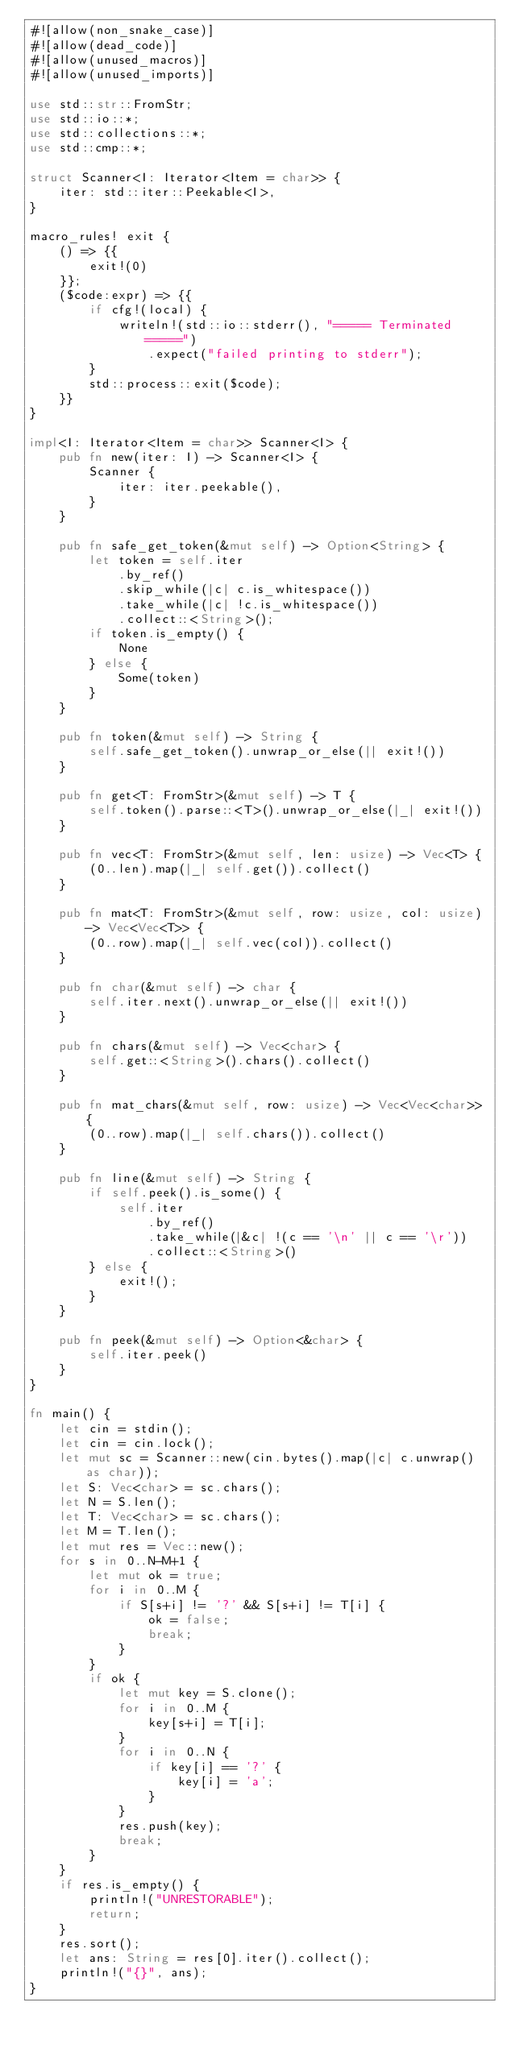<code> <loc_0><loc_0><loc_500><loc_500><_Rust_>#![allow(non_snake_case)]
#![allow(dead_code)]
#![allow(unused_macros)]
#![allow(unused_imports)]

use std::str::FromStr;
use std::io::*;
use std::collections::*;
use std::cmp::*;

struct Scanner<I: Iterator<Item = char>> {
    iter: std::iter::Peekable<I>,
}

macro_rules! exit {
    () => {{
        exit!(0)
    }};
    ($code:expr) => {{
        if cfg!(local) {
            writeln!(std::io::stderr(), "===== Terminated =====")
                .expect("failed printing to stderr");
        }
        std::process::exit($code);
    }}
}

impl<I: Iterator<Item = char>> Scanner<I> {
    pub fn new(iter: I) -> Scanner<I> {
        Scanner {
            iter: iter.peekable(),
        }
    }

    pub fn safe_get_token(&mut self) -> Option<String> {
        let token = self.iter
            .by_ref()
            .skip_while(|c| c.is_whitespace())
            .take_while(|c| !c.is_whitespace())
            .collect::<String>();
        if token.is_empty() {
            None
        } else {
            Some(token)
        }
    }

    pub fn token(&mut self) -> String {
        self.safe_get_token().unwrap_or_else(|| exit!())
    }

    pub fn get<T: FromStr>(&mut self) -> T {
        self.token().parse::<T>().unwrap_or_else(|_| exit!())
    }

    pub fn vec<T: FromStr>(&mut self, len: usize) -> Vec<T> {
        (0..len).map(|_| self.get()).collect()
    }

    pub fn mat<T: FromStr>(&mut self, row: usize, col: usize) -> Vec<Vec<T>> {
        (0..row).map(|_| self.vec(col)).collect()
    }

    pub fn char(&mut self) -> char {
        self.iter.next().unwrap_or_else(|| exit!())
    }

    pub fn chars(&mut self) -> Vec<char> {
        self.get::<String>().chars().collect()
    }

    pub fn mat_chars(&mut self, row: usize) -> Vec<Vec<char>> {
        (0..row).map(|_| self.chars()).collect()
    }

    pub fn line(&mut self) -> String {
        if self.peek().is_some() {
            self.iter
                .by_ref()
                .take_while(|&c| !(c == '\n' || c == '\r'))
                .collect::<String>()
        } else {
            exit!();
        }
    }

    pub fn peek(&mut self) -> Option<&char> {
        self.iter.peek()
    }
}

fn main() {
    let cin = stdin();
    let cin = cin.lock();
    let mut sc = Scanner::new(cin.bytes().map(|c| c.unwrap() as char));
    let S: Vec<char> = sc.chars();
    let N = S.len();
    let T: Vec<char> = sc.chars();
    let M = T.len();
    let mut res = Vec::new();
    for s in 0..N-M+1 {
        let mut ok = true;
        for i in 0..M {
            if S[s+i] != '?' && S[s+i] != T[i] {
                ok = false;
                break;
            }
        }
        if ok {
            let mut key = S.clone();
            for i in 0..M {
                key[s+i] = T[i];
            }
            for i in 0..N {
                if key[i] == '?' {
                    key[i] = 'a';
                }
            }
            res.push(key);
            break;
        }
    }
    if res.is_empty() {
        println!("UNRESTORABLE");
        return;
    }
    res.sort();
    let ans: String = res[0].iter().collect();
    println!("{}", ans);
}
</code> 